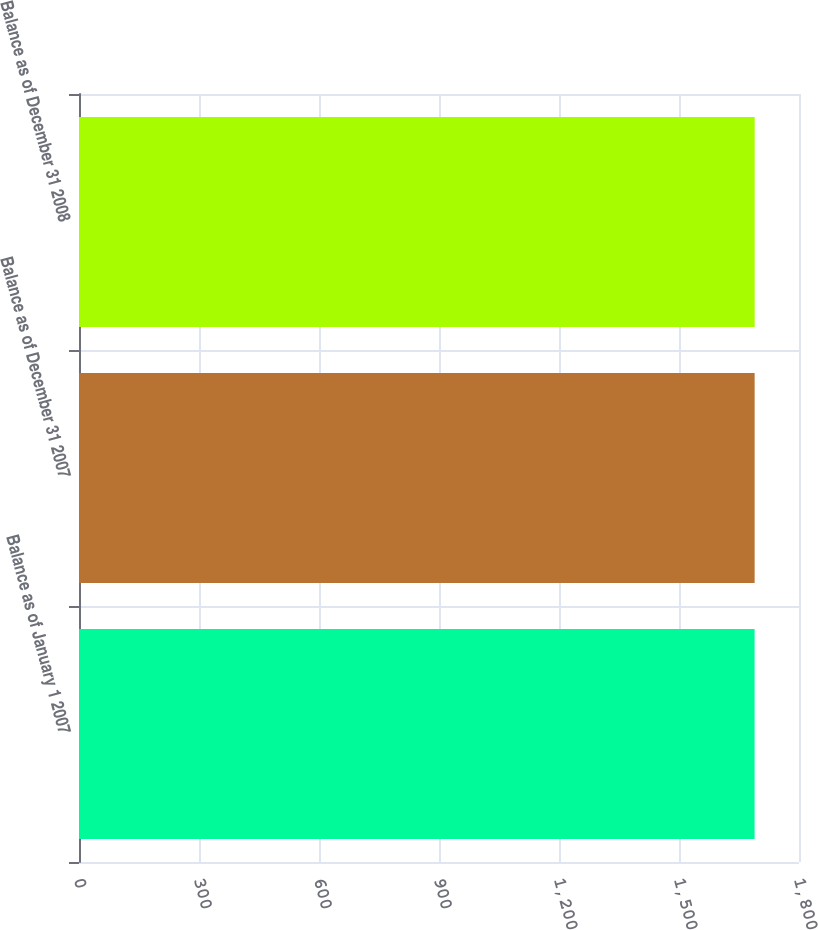Convert chart to OTSL. <chart><loc_0><loc_0><loc_500><loc_500><bar_chart><fcel>Balance as of January 1 2007<fcel>Balance as of December 31 2007<fcel>Balance as of December 31 2008<nl><fcel>1689<fcel>1689.1<fcel>1689.2<nl></chart> 